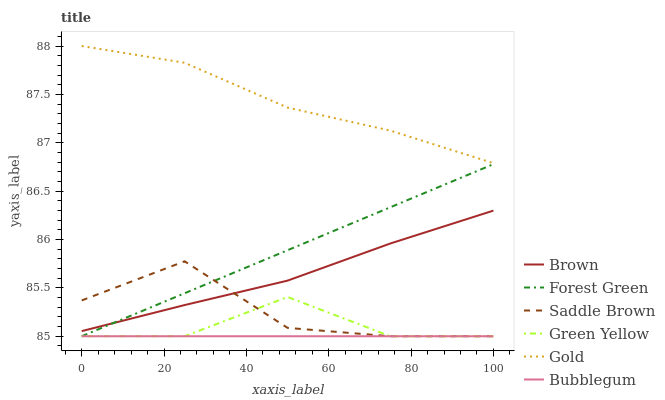Does Bubblegum have the minimum area under the curve?
Answer yes or no. Yes. Does Gold have the maximum area under the curve?
Answer yes or no. Yes. Does Gold have the minimum area under the curve?
Answer yes or no. No. Does Bubblegum have the maximum area under the curve?
Answer yes or no. No. Is Bubblegum the smoothest?
Answer yes or no. Yes. Is Saddle Brown the roughest?
Answer yes or no. Yes. Is Gold the smoothest?
Answer yes or no. No. Is Gold the roughest?
Answer yes or no. No. Does Bubblegum have the lowest value?
Answer yes or no. Yes. Does Gold have the lowest value?
Answer yes or no. No. Does Gold have the highest value?
Answer yes or no. Yes. Does Bubblegum have the highest value?
Answer yes or no. No. Is Forest Green less than Gold?
Answer yes or no. Yes. Is Gold greater than Bubblegum?
Answer yes or no. Yes. Does Brown intersect Saddle Brown?
Answer yes or no. Yes. Is Brown less than Saddle Brown?
Answer yes or no. No. Is Brown greater than Saddle Brown?
Answer yes or no. No. Does Forest Green intersect Gold?
Answer yes or no. No. 